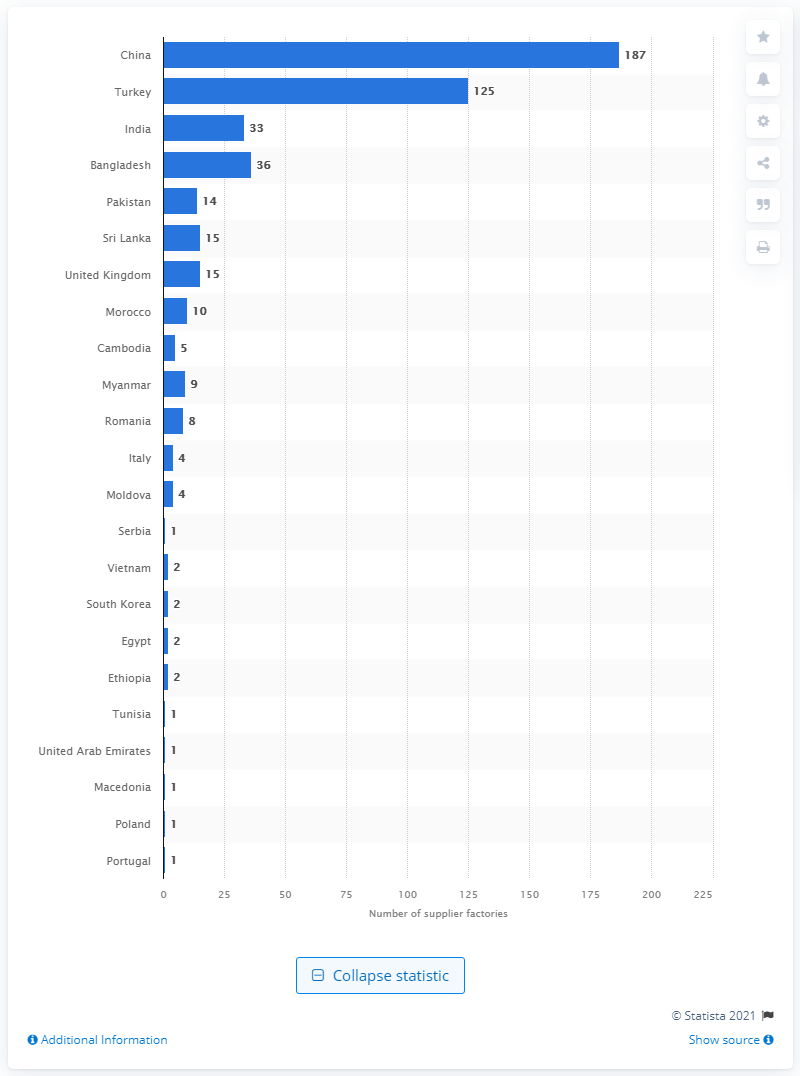Indicate a few pertinent items in this graphic. New Look has 15 supplier factories in the UK. 